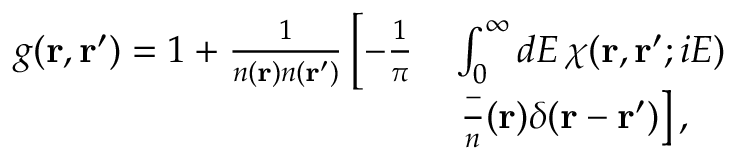<formula> <loc_0><loc_0><loc_500><loc_500>\begin{array} { r l } { g ( r , r ^ { \prime } ) = 1 + \frac { 1 } { n ( r ) n ( r ^ { \prime } ) } \left [ - \frac { 1 } { \pi } } & { \int _ { 0 } ^ { \infty } d E \, \chi ( r , r ^ { \prime } ; i E ) } \\ & { \frac { - } { n } ( r ) \delta ( r - r ^ { \prime } ) \right ] , } \end{array}</formula> 